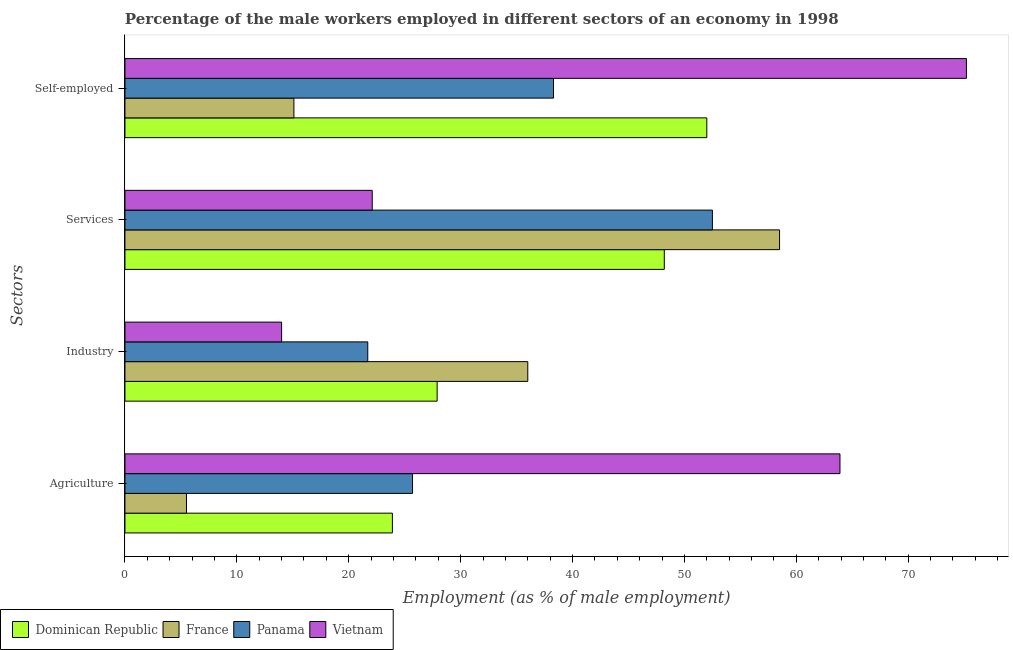How many different coloured bars are there?
Ensure brevity in your answer.  4. Are the number of bars per tick equal to the number of legend labels?
Keep it short and to the point. Yes. Are the number of bars on each tick of the Y-axis equal?
Provide a succinct answer. Yes. How many bars are there on the 4th tick from the bottom?
Ensure brevity in your answer.  4. What is the label of the 1st group of bars from the top?
Offer a very short reply. Self-employed. What is the percentage of self employed male workers in France?
Provide a short and direct response. 15.1. In which country was the percentage of male workers in agriculture maximum?
Your response must be concise. Vietnam. In which country was the percentage of self employed male workers minimum?
Make the answer very short. France. What is the total percentage of male workers in services in the graph?
Your answer should be very brief. 181.3. What is the difference between the percentage of male workers in agriculture in France and that in Dominican Republic?
Provide a short and direct response. -18.4. What is the difference between the percentage of male workers in industry in Panama and the percentage of male workers in agriculture in Dominican Republic?
Offer a very short reply. -2.2. What is the average percentage of male workers in services per country?
Your answer should be very brief. 45.33. What is the difference between the percentage of self employed male workers and percentage of male workers in industry in Dominican Republic?
Your answer should be very brief. 24.1. In how many countries, is the percentage of male workers in agriculture greater than 72 %?
Your answer should be compact. 0. What is the ratio of the percentage of male workers in services in Dominican Republic to that in France?
Offer a terse response. 0.82. What is the difference between the highest and the lowest percentage of male workers in services?
Your answer should be compact. 36.4. Is the sum of the percentage of male workers in services in Vietnam and Panama greater than the maximum percentage of male workers in agriculture across all countries?
Provide a succinct answer. Yes. Is it the case that in every country, the sum of the percentage of male workers in industry and percentage of self employed male workers is greater than the sum of percentage of male workers in services and percentage of male workers in agriculture?
Your response must be concise. Yes. What does the 2nd bar from the top in Agriculture represents?
Offer a terse response. Panama. What does the 3rd bar from the bottom in Agriculture represents?
Ensure brevity in your answer.  Panama. How many countries are there in the graph?
Make the answer very short. 4. What is the difference between two consecutive major ticks on the X-axis?
Make the answer very short. 10. Are the values on the major ticks of X-axis written in scientific E-notation?
Make the answer very short. No. Does the graph contain any zero values?
Offer a terse response. No. How are the legend labels stacked?
Give a very brief answer. Horizontal. What is the title of the graph?
Offer a very short reply. Percentage of the male workers employed in different sectors of an economy in 1998. What is the label or title of the X-axis?
Provide a succinct answer. Employment (as % of male employment). What is the label or title of the Y-axis?
Your response must be concise. Sectors. What is the Employment (as % of male employment) of Dominican Republic in Agriculture?
Ensure brevity in your answer.  23.9. What is the Employment (as % of male employment) of France in Agriculture?
Your response must be concise. 5.5. What is the Employment (as % of male employment) in Panama in Agriculture?
Offer a terse response. 25.7. What is the Employment (as % of male employment) of Vietnam in Agriculture?
Provide a short and direct response. 63.9. What is the Employment (as % of male employment) in Dominican Republic in Industry?
Keep it short and to the point. 27.9. What is the Employment (as % of male employment) in Panama in Industry?
Give a very brief answer. 21.7. What is the Employment (as % of male employment) in Vietnam in Industry?
Keep it short and to the point. 14. What is the Employment (as % of male employment) in Dominican Republic in Services?
Provide a short and direct response. 48.2. What is the Employment (as % of male employment) in France in Services?
Give a very brief answer. 58.5. What is the Employment (as % of male employment) in Panama in Services?
Your answer should be very brief. 52.5. What is the Employment (as % of male employment) of Vietnam in Services?
Keep it short and to the point. 22.1. What is the Employment (as % of male employment) in France in Self-employed?
Keep it short and to the point. 15.1. What is the Employment (as % of male employment) of Panama in Self-employed?
Keep it short and to the point. 38.3. What is the Employment (as % of male employment) in Vietnam in Self-employed?
Your response must be concise. 75.2. Across all Sectors, what is the maximum Employment (as % of male employment) in France?
Your answer should be very brief. 58.5. Across all Sectors, what is the maximum Employment (as % of male employment) in Panama?
Ensure brevity in your answer.  52.5. Across all Sectors, what is the maximum Employment (as % of male employment) of Vietnam?
Keep it short and to the point. 75.2. Across all Sectors, what is the minimum Employment (as % of male employment) in Dominican Republic?
Ensure brevity in your answer.  23.9. Across all Sectors, what is the minimum Employment (as % of male employment) of France?
Your response must be concise. 5.5. Across all Sectors, what is the minimum Employment (as % of male employment) in Panama?
Your response must be concise. 21.7. Across all Sectors, what is the minimum Employment (as % of male employment) of Vietnam?
Provide a succinct answer. 14. What is the total Employment (as % of male employment) in Dominican Republic in the graph?
Provide a succinct answer. 152. What is the total Employment (as % of male employment) of France in the graph?
Keep it short and to the point. 115.1. What is the total Employment (as % of male employment) in Panama in the graph?
Provide a succinct answer. 138.2. What is the total Employment (as % of male employment) of Vietnam in the graph?
Your answer should be compact. 175.2. What is the difference between the Employment (as % of male employment) in France in Agriculture and that in Industry?
Provide a short and direct response. -30.5. What is the difference between the Employment (as % of male employment) in Vietnam in Agriculture and that in Industry?
Your response must be concise. 49.9. What is the difference between the Employment (as % of male employment) of Dominican Republic in Agriculture and that in Services?
Keep it short and to the point. -24.3. What is the difference between the Employment (as % of male employment) in France in Agriculture and that in Services?
Your answer should be compact. -53. What is the difference between the Employment (as % of male employment) in Panama in Agriculture and that in Services?
Your response must be concise. -26.8. What is the difference between the Employment (as % of male employment) of Vietnam in Agriculture and that in Services?
Offer a very short reply. 41.8. What is the difference between the Employment (as % of male employment) of Dominican Republic in Agriculture and that in Self-employed?
Your response must be concise. -28.1. What is the difference between the Employment (as % of male employment) of France in Agriculture and that in Self-employed?
Your answer should be compact. -9.6. What is the difference between the Employment (as % of male employment) of Panama in Agriculture and that in Self-employed?
Make the answer very short. -12.6. What is the difference between the Employment (as % of male employment) of Vietnam in Agriculture and that in Self-employed?
Your answer should be very brief. -11.3. What is the difference between the Employment (as % of male employment) of Dominican Republic in Industry and that in Services?
Provide a short and direct response. -20.3. What is the difference between the Employment (as % of male employment) in France in Industry and that in Services?
Provide a short and direct response. -22.5. What is the difference between the Employment (as % of male employment) of Panama in Industry and that in Services?
Provide a succinct answer. -30.8. What is the difference between the Employment (as % of male employment) in Vietnam in Industry and that in Services?
Provide a short and direct response. -8.1. What is the difference between the Employment (as % of male employment) of Dominican Republic in Industry and that in Self-employed?
Offer a terse response. -24.1. What is the difference between the Employment (as % of male employment) of France in Industry and that in Self-employed?
Give a very brief answer. 20.9. What is the difference between the Employment (as % of male employment) of Panama in Industry and that in Self-employed?
Make the answer very short. -16.6. What is the difference between the Employment (as % of male employment) in Vietnam in Industry and that in Self-employed?
Give a very brief answer. -61.2. What is the difference between the Employment (as % of male employment) in France in Services and that in Self-employed?
Provide a succinct answer. 43.4. What is the difference between the Employment (as % of male employment) of Panama in Services and that in Self-employed?
Your response must be concise. 14.2. What is the difference between the Employment (as % of male employment) of Vietnam in Services and that in Self-employed?
Make the answer very short. -53.1. What is the difference between the Employment (as % of male employment) in Dominican Republic in Agriculture and the Employment (as % of male employment) in France in Industry?
Your answer should be compact. -12.1. What is the difference between the Employment (as % of male employment) in Dominican Republic in Agriculture and the Employment (as % of male employment) in Panama in Industry?
Give a very brief answer. 2.2. What is the difference between the Employment (as % of male employment) of France in Agriculture and the Employment (as % of male employment) of Panama in Industry?
Ensure brevity in your answer.  -16.2. What is the difference between the Employment (as % of male employment) of Dominican Republic in Agriculture and the Employment (as % of male employment) of France in Services?
Give a very brief answer. -34.6. What is the difference between the Employment (as % of male employment) in Dominican Republic in Agriculture and the Employment (as % of male employment) in Panama in Services?
Keep it short and to the point. -28.6. What is the difference between the Employment (as % of male employment) in France in Agriculture and the Employment (as % of male employment) in Panama in Services?
Provide a succinct answer. -47. What is the difference between the Employment (as % of male employment) in France in Agriculture and the Employment (as % of male employment) in Vietnam in Services?
Keep it short and to the point. -16.6. What is the difference between the Employment (as % of male employment) in Panama in Agriculture and the Employment (as % of male employment) in Vietnam in Services?
Your answer should be compact. 3.6. What is the difference between the Employment (as % of male employment) of Dominican Republic in Agriculture and the Employment (as % of male employment) of Panama in Self-employed?
Keep it short and to the point. -14.4. What is the difference between the Employment (as % of male employment) of Dominican Republic in Agriculture and the Employment (as % of male employment) of Vietnam in Self-employed?
Provide a succinct answer. -51.3. What is the difference between the Employment (as % of male employment) of France in Agriculture and the Employment (as % of male employment) of Panama in Self-employed?
Provide a succinct answer. -32.8. What is the difference between the Employment (as % of male employment) of France in Agriculture and the Employment (as % of male employment) of Vietnam in Self-employed?
Your response must be concise. -69.7. What is the difference between the Employment (as % of male employment) of Panama in Agriculture and the Employment (as % of male employment) of Vietnam in Self-employed?
Offer a very short reply. -49.5. What is the difference between the Employment (as % of male employment) in Dominican Republic in Industry and the Employment (as % of male employment) in France in Services?
Give a very brief answer. -30.6. What is the difference between the Employment (as % of male employment) of Dominican Republic in Industry and the Employment (as % of male employment) of Panama in Services?
Your answer should be compact. -24.6. What is the difference between the Employment (as % of male employment) of France in Industry and the Employment (as % of male employment) of Panama in Services?
Make the answer very short. -16.5. What is the difference between the Employment (as % of male employment) in Panama in Industry and the Employment (as % of male employment) in Vietnam in Services?
Provide a short and direct response. -0.4. What is the difference between the Employment (as % of male employment) of Dominican Republic in Industry and the Employment (as % of male employment) of Vietnam in Self-employed?
Offer a terse response. -47.3. What is the difference between the Employment (as % of male employment) in France in Industry and the Employment (as % of male employment) in Panama in Self-employed?
Provide a succinct answer. -2.3. What is the difference between the Employment (as % of male employment) of France in Industry and the Employment (as % of male employment) of Vietnam in Self-employed?
Offer a terse response. -39.2. What is the difference between the Employment (as % of male employment) in Panama in Industry and the Employment (as % of male employment) in Vietnam in Self-employed?
Give a very brief answer. -53.5. What is the difference between the Employment (as % of male employment) in Dominican Republic in Services and the Employment (as % of male employment) in France in Self-employed?
Make the answer very short. 33.1. What is the difference between the Employment (as % of male employment) of Dominican Republic in Services and the Employment (as % of male employment) of Panama in Self-employed?
Ensure brevity in your answer.  9.9. What is the difference between the Employment (as % of male employment) in France in Services and the Employment (as % of male employment) in Panama in Self-employed?
Offer a very short reply. 20.2. What is the difference between the Employment (as % of male employment) of France in Services and the Employment (as % of male employment) of Vietnam in Self-employed?
Your response must be concise. -16.7. What is the difference between the Employment (as % of male employment) in Panama in Services and the Employment (as % of male employment) in Vietnam in Self-employed?
Offer a terse response. -22.7. What is the average Employment (as % of male employment) in Dominican Republic per Sectors?
Offer a very short reply. 38. What is the average Employment (as % of male employment) in France per Sectors?
Make the answer very short. 28.77. What is the average Employment (as % of male employment) in Panama per Sectors?
Offer a terse response. 34.55. What is the average Employment (as % of male employment) of Vietnam per Sectors?
Make the answer very short. 43.8. What is the difference between the Employment (as % of male employment) in Dominican Republic and Employment (as % of male employment) in France in Agriculture?
Provide a short and direct response. 18.4. What is the difference between the Employment (as % of male employment) of Dominican Republic and Employment (as % of male employment) of Panama in Agriculture?
Keep it short and to the point. -1.8. What is the difference between the Employment (as % of male employment) of France and Employment (as % of male employment) of Panama in Agriculture?
Your response must be concise. -20.2. What is the difference between the Employment (as % of male employment) in France and Employment (as % of male employment) in Vietnam in Agriculture?
Ensure brevity in your answer.  -58.4. What is the difference between the Employment (as % of male employment) of Panama and Employment (as % of male employment) of Vietnam in Agriculture?
Keep it short and to the point. -38.2. What is the difference between the Employment (as % of male employment) in Dominican Republic and Employment (as % of male employment) in France in Industry?
Offer a terse response. -8.1. What is the difference between the Employment (as % of male employment) of Dominican Republic and Employment (as % of male employment) of Panama in Industry?
Offer a terse response. 6.2. What is the difference between the Employment (as % of male employment) in France and Employment (as % of male employment) in Panama in Industry?
Your response must be concise. 14.3. What is the difference between the Employment (as % of male employment) in Dominican Republic and Employment (as % of male employment) in France in Services?
Your answer should be very brief. -10.3. What is the difference between the Employment (as % of male employment) in Dominican Republic and Employment (as % of male employment) in Panama in Services?
Make the answer very short. -4.3. What is the difference between the Employment (as % of male employment) of Dominican Republic and Employment (as % of male employment) of Vietnam in Services?
Give a very brief answer. 26.1. What is the difference between the Employment (as % of male employment) in France and Employment (as % of male employment) in Panama in Services?
Your answer should be very brief. 6. What is the difference between the Employment (as % of male employment) in France and Employment (as % of male employment) in Vietnam in Services?
Offer a very short reply. 36.4. What is the difference between the Employment (as % of male employment) of Panama and Employment (as % of male employment) of Vietnam in Services?
Your answer should be very brief. 30.4. What is the difference between the Employment (as % of male employment) in Dominican Republic and Employment (as % of male employment) in France in Self-employed?
Make the answer very short. 36.9. What is the difference between the Employment (as % of male employment) of Dominican Republic and Employment (as % of male employment) of Panama in Self-employed?
Offer a very short reply. 13.7. What is the difference between the Employment (as % of male employment) in Dominican Republic and Employment (as % of male employment) in Vietnam in Self-employed?
Your answer should be compact. -23.2. What is the difference between the Employment (as % of male employment) of France and Employment (as % of male employment) of Panama in Self-employed?
Offer a very short reply. -23.2. What is the difference between the Employment (as % of male employment) in France and Employment (as % of male employment) in Vietnam in Self-employed?
Keep it short and to the point. -60.1. What is the difference between the Employment (as % of male employment) of Panama and Employment (as % of male employment) of Vietnam in Self-employed?
Keep it short and to the point. -36.9. What is the ratio of the Employment (as % of male employment) of Dominican Republic in Agriculture to that in Industry?
Give a very brief answer. 0.86. What is the ratio of the Employment (as % of male employment) in France in Agriculture to that in Industry?
Your answer should be very brief. 0.15. What is the ratio of the Employment (as % of male employment) of Panama in Agriculture to that in Industry?
Offer a very short reply. 1.18. What is the ratio of the Employment (as % of male employment) in Vietnam in Agriculture to that in Industry?
Make the answer very short. 4.56. What is the ratio of the Employment (as % of male employment) of Dominican Republic in Agriculture to that in Services?
Your response must be concise. 0.5. What is the ratio of the Employment (as % of male employment) in France in Agriculture to that in Services?
Your answer should be compact. 0.09. What is the ratio of the Employment (as % of male employment) in Panama in Agriculture to that in Services?
Offer a very short reply. 0.49. What is the ratio of the Employment (as % of male employment) in Vietnam in Agriculture to that in Services?
Keep it short and to the point. 2.89. What is the ratio of the Employment (as % of male employment) of Dominican Republic in Agriculture to that in Self-employed?
Your answer should be very brief. 0.46. What is the ratio of the Employment (as % of male employment) of France in Agriculture to that in Self-employed?
Offer a terse response. 0.36. What is the ratio of the Employment (as % of male employment) in Panama in Agriculture to that in Self-employed?
Offer a terse response. 0.67. What is the ratio of the Employment (as % of male employment) in Vietnam in Agriculture to that in Self-employed?
Offer a very short reply. 0.85. What is the ratio of the Employment (as % of male employment) of Dominican Republic in Industry to that in Services?
Your answer should be compact. 0.58. What is the ratio of the Employment (as % of male employment) of France in Industry to that in Services?
Ensure brevity in your answer.  0.62. What is the ratio of the Employment (as % of male employment) of Panama in Industry to that in Services?
Offer a very short reply. 0.41. What is the ratio of the Employment (as % of male employment) in Vietnam in Industry to that in Services?
Offer a very short reply. 0.63. What is the ratio of the Employment (as % of male employment) of Dominican Republic in Industry to that in Self-employed?
Your answer should be very brief. 0.54. What is the ratio of the Employment (as % of male employment) in France in Industry to that in Self-employed?
Provide a succinct answer. 2.38. What is the ratio of the Employment (as % of male employment) of Panama in Industry to that in Self-employed?
Keep it short and to the point. 0.57. What is the ratio of the Employment (as % of male employment) of Vietnam in Industry to that in Self-employed?
Ensure brevity in your answer.  0.19. What is the ratio of the Employment (as % of male employment) in Dominican Republic in Services to that in Self-employed?
Your answer should be very brief. 0.93. What is the ratio of the Employment (as % of male employment) of France in Services to that in Self-employed?
Give a very brief answer. 3.87. What is the ratio of the Employment (as % of male employment) of Panama in Services to that in Self-employed?
Ensure brevity in your answer.  1.37. What is the ratio of the Employment (as % of male employment) in Vietnam in Services to that in Self-employed?
Make the answer very short. 0.29. What is the difference between the highest and the second highest Employment (as % of male employment) in Panama?
Your answer should be compact. 14.2. What is the difference between the highest and the second highest Employment (as % of male employment) in Vietnam?
Give a very brief answer. 11.3. What is the difference between the highest and the lowest Employment (as % of male employment) in Dominican Republic?
Give a very brief answer. 28.1. What is the difference between the highest and the lowest Employment (as % of male employment) of France?
Your response must be concise. 53. What is the difference between the highest and the lowest Employment (as % of male employment) of Panama?
Offer a very short reply. 30.8. What is the difference between the highest and the lowest Employment (as % of male employment) of Vietnam?
Provide a short and direct response. 61.2. 